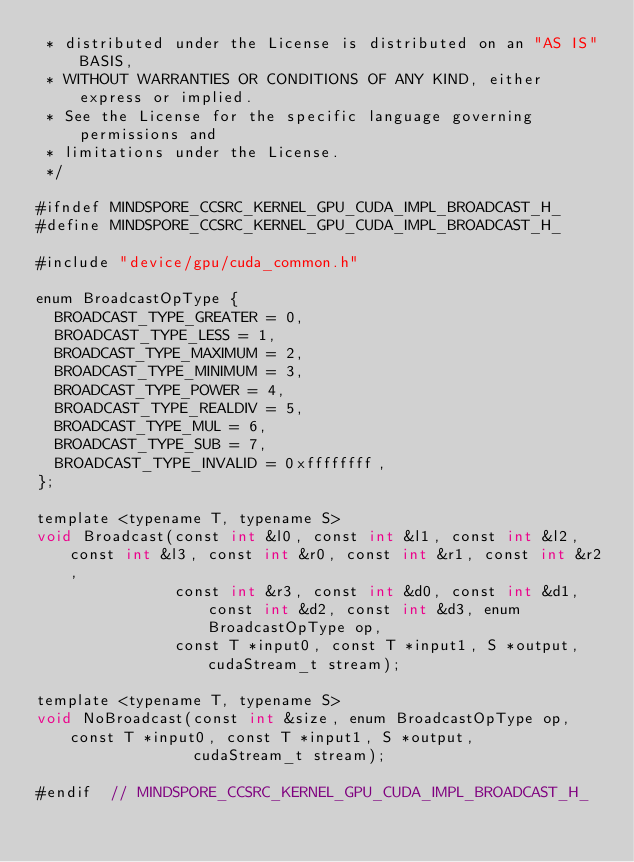Convert code to text. <code><loc_0><loc_0><loc_500><loc_500><_Cuda_> * distributed under the License is distributed on an "AS IS" BASIS,
 * WITHOUT WARRANTIES OR CONDITIONS OF ANY KIND, either express or implied.
 * See the License for the specific language governing permissions and
 * limitations under the License.
 */

#ifndef MINDSPORE_CCSRC_KERNEL_GPU_CUDA_IMPL_BROADCAST_H_
#define MINDSPORE_CCSRC_KERNEL_GPU_CUDA_IMPL_BROADCAST_H_

#include "device/gpu/cuda_common.h"

enum BroadcastOpType {
  BROADCAST_TYPE_GREATER = 0,
  BROADCAST_TYPE_LESS = 1,
  BROADCAST_TYPE_MAXIMUM = 2,
  BROADCAST_TYPE_MINIMUM = 3,
  BROADCAST_TYPE_POWER = 4,
  BROADCAST_TYPE_REALDIV = 5,
  BROADCAST_TYPE_MUL = 6,
  BROADCAST_TYPE_SUB = 7,
  BROADCAST_TYPE_INVALID = 0xffffffff,
};

template <typename T, typename S>
void Broadcast(const int &l0, const int &l1, const int &l2, const int &l3, const int &r0, const int &r1, const int &r2,
               const int &r3, const int &d0, const int &d1, const int &d2, const int &d3, enum BroadcastOpType op,
               const T *input0, const T *input1, S *output, cudaStream_t stream);

template <typename T, typename S>
void NoBroadcast(const int &size, enum BroadcastOpType op, const T *input0, const T *input1, S *output,
                 cudaStream_t stream);

#endif  // MINDSPORE_CCSRC_KERNEL_GPU_CUDA_IMPL_BROADCAST_H_
</code> 